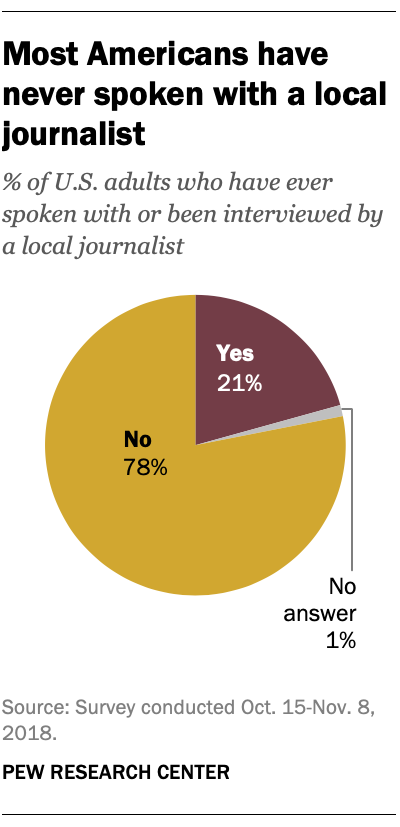Indicate a few pertinent items in this graphic. The percentage of individuals answering "no" is 78%. The ratio between answering yes and no is approximately 0.309722222... 